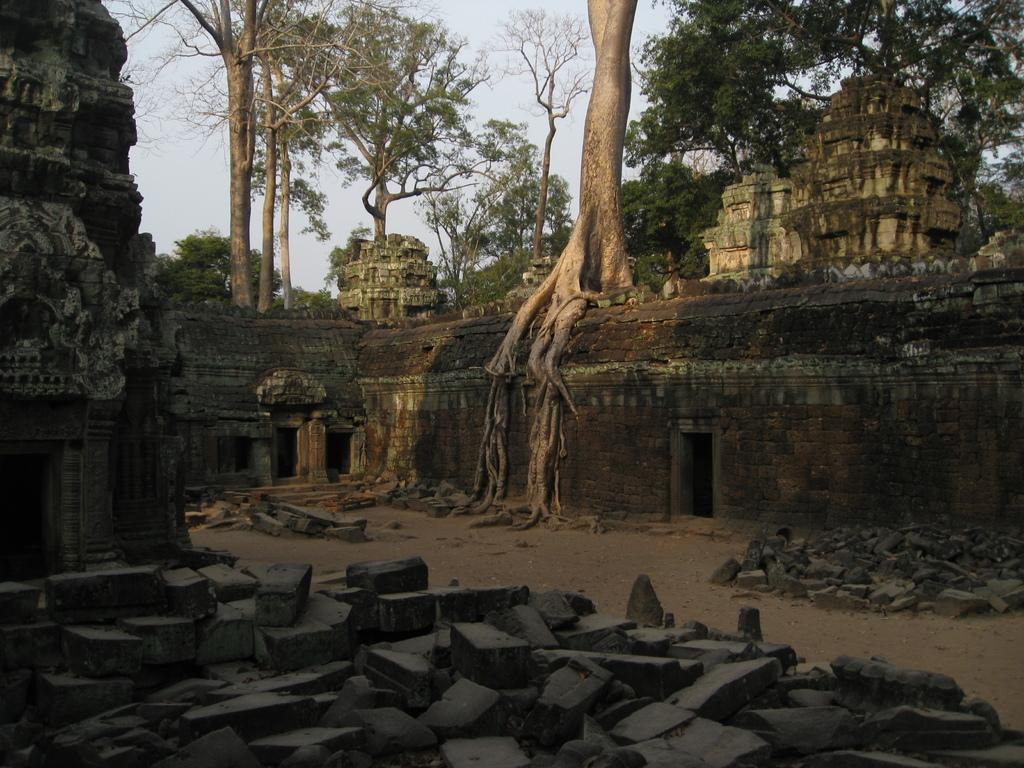What type of natural elements can be seen in the image? There are stones and trees in the image. What man-made structures are present in the image? There are temples in the image. What can be seen in the background of the image? The sky is visible in the background of the image. What type of oatmeal is being used as bait in the image? There is no oatmeal or bait present in the image; it features stones, temples, trees, and the sky. What boundary is depicted in the image? There is no boundary depicted in the image; it shows a natural and man-made landscape. 